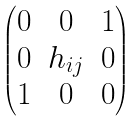<formula> <loc_0><loc_0><loc_500><loc_500>\begin{pmatrix} 0 & 0 & 1 \\ 0 & h _ { i j } & 0 \\ 1 & 0 & 0 \end{pmatrix}</formula> 